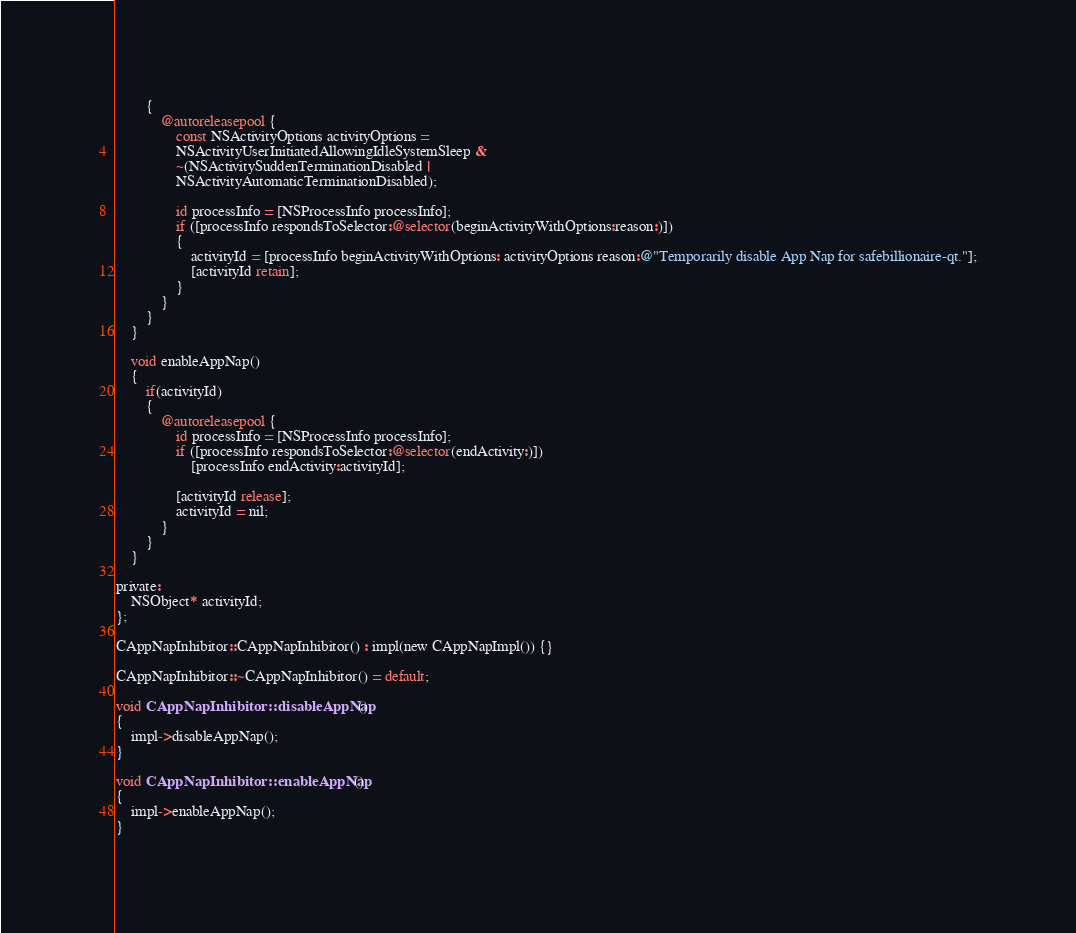Convert code to text. <code><loc_0><loc_0><loc_500><loc_500><_ObjectiveC_>        {
            @autoreleasepool {
                const NSActivityOptions activityOptions =
                NSActivityUserInitiatedAllowingIdleSystemSleep &
                ~(NSActivitySuddenTerminationDisabled |
                NSActivityAutomaticTerminationDisabled);

                id processInfo = [NSProcessInfo processInfo];
                if ([processInfo respondsToSelector:@selector(beginActivityWithOptions:reason:)])
                {
                    activityId = [processInfo beginActivityWithOptions: activityOptions reason:@"Temporarily disable App Nap for safebillionaire-qt."];
                    [activityId retain];
                }
            }
        }
    }

    void enableAppNap()
    {
        if(activityId)
        {
            @autoreleasepool {
                id processInfo = [NSProcessInfo processInfo];
                if ([processInfo respondsToSelector:@selector(endActivity:)])
                    [processInfo endActivity:activityId];

                [activityId release];
                activityId = nil;
            }
        }
    }

private:
    NSObject* activityId;
};

CAppNapInhibitor::CAppNapInhibitor() : impl(new CAppNapImpl()) {}

CAppNapInhibitor::~CAppNapInhibitor() = default;

void CAppNapInhibitor::disableAppNap()
{
    impl->disableAppNap();
}

void CAppNapInhibitor::enableAppNap()
{
    impl->enableAppNap();
}
</code> 